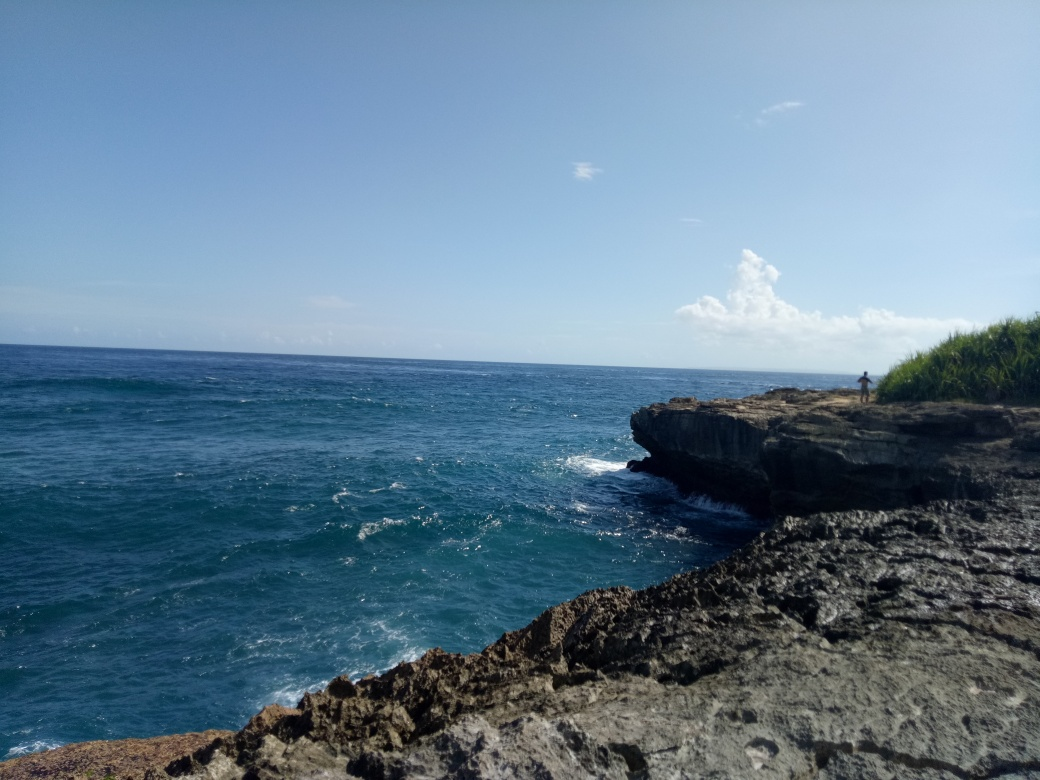Can you describe the geological features present in this image? Certainly! The coastline features jagged, erosion-resistant rock formations, likely limestone, that demonstrate some form of karst topography. The visible strata suggest sedimentary layers, hinting at a dynamic geological history involving water and tectonic activities. 